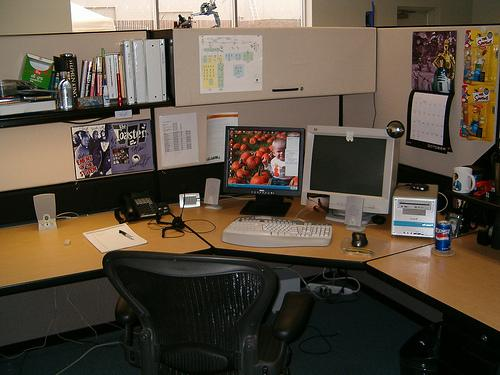Briefly describe a scene that involves several objects found in the image. In an office setting, there is a wooden desk with dual computer monitors, a black office chair, a white keyboard with wrist rest, and a Star Wars calendar on the wall. What kind of furniture is prominently shown in the image? A wooden desk, a black high-backed office chair, and beige overhead storage are prominently shown. Provide a brief overview of the overall scene depicted in the image. The image shows an interior office scene with natural daylight, featuring various office supplies, furniture, and Star Wars calendar on the wall. Choose an object in the image and explain its purpose or function. The ergonomical black office desk chair provides comfortable seating and support while working at the desk. Identify an object in the image with a unique feature, and describe the feature. There is a Star Wars calendar in the image, featuring characters from the popular film franchise. Mention an electronic device visible in the image and describe its features. There are two computer monitors side by side on a desk, with one screen displaying pumpkins and a baby while the other is off. State the contents and nature of a specific object in the image. The white coffee mug in the image has a colorful decoration, possibly featuring a person on it. Identify any unique or iconic imagery present in the image. The calendar in the image features Star Wars characters, an iconic and well-known film franchise. Describe a small item that can be found in the image and its location. A small can of Pepsi is sitting on a desk in the image, near the edge of the photograph. Select an object in the image and provide a detailed description of its placement and appearance. The open window in the image is positioned in the background, showing the outside view through a bottom portion, allowing natural light into the office cubicle. 